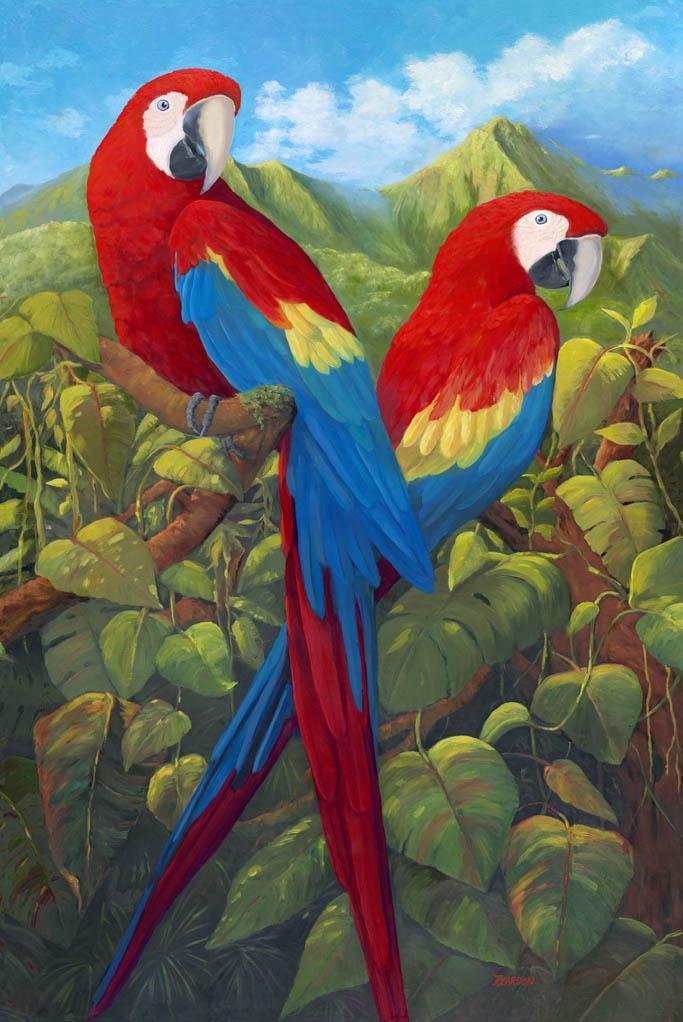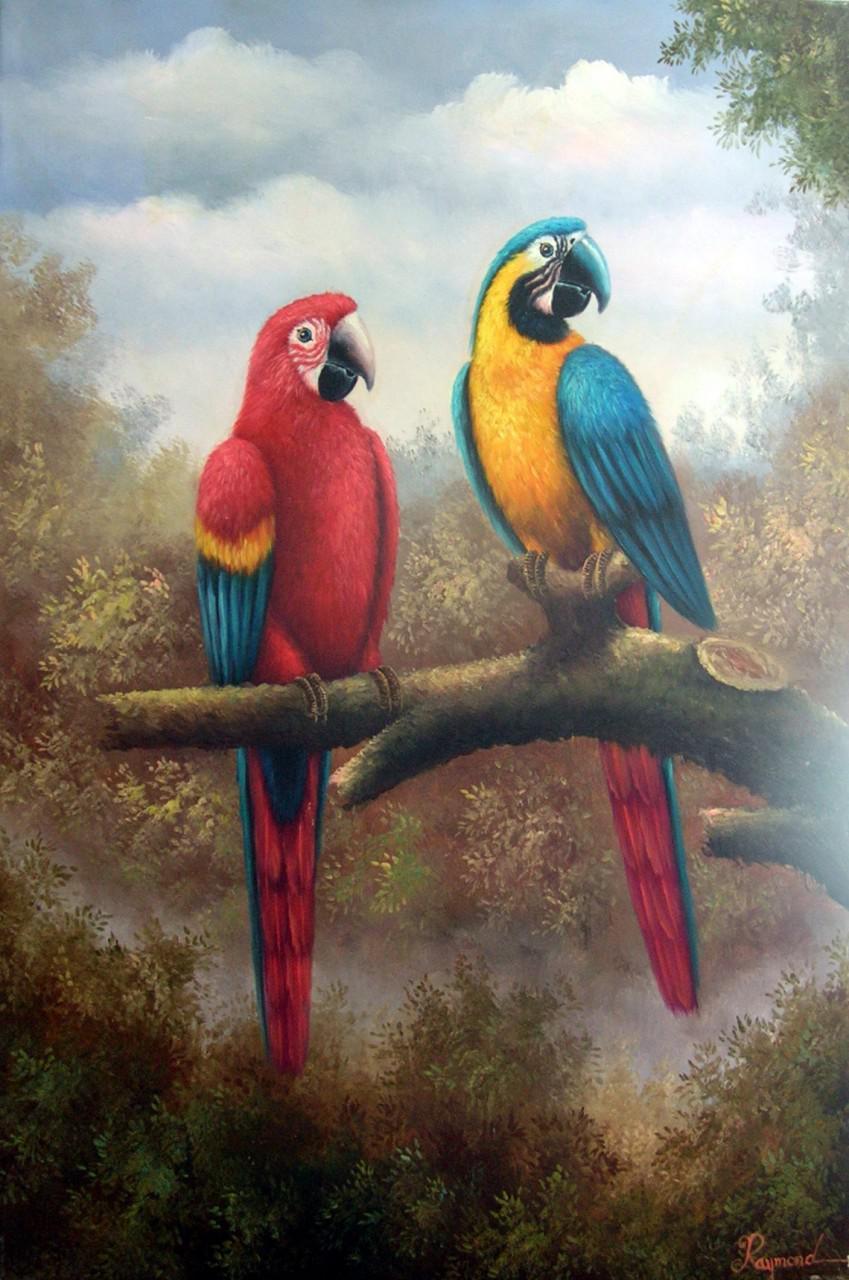The first image is the image on the left, the second image is the image on the right. For the images shown, is this caption "An image includes two colorful parrots in flight." true? Answer yes or no. No. 